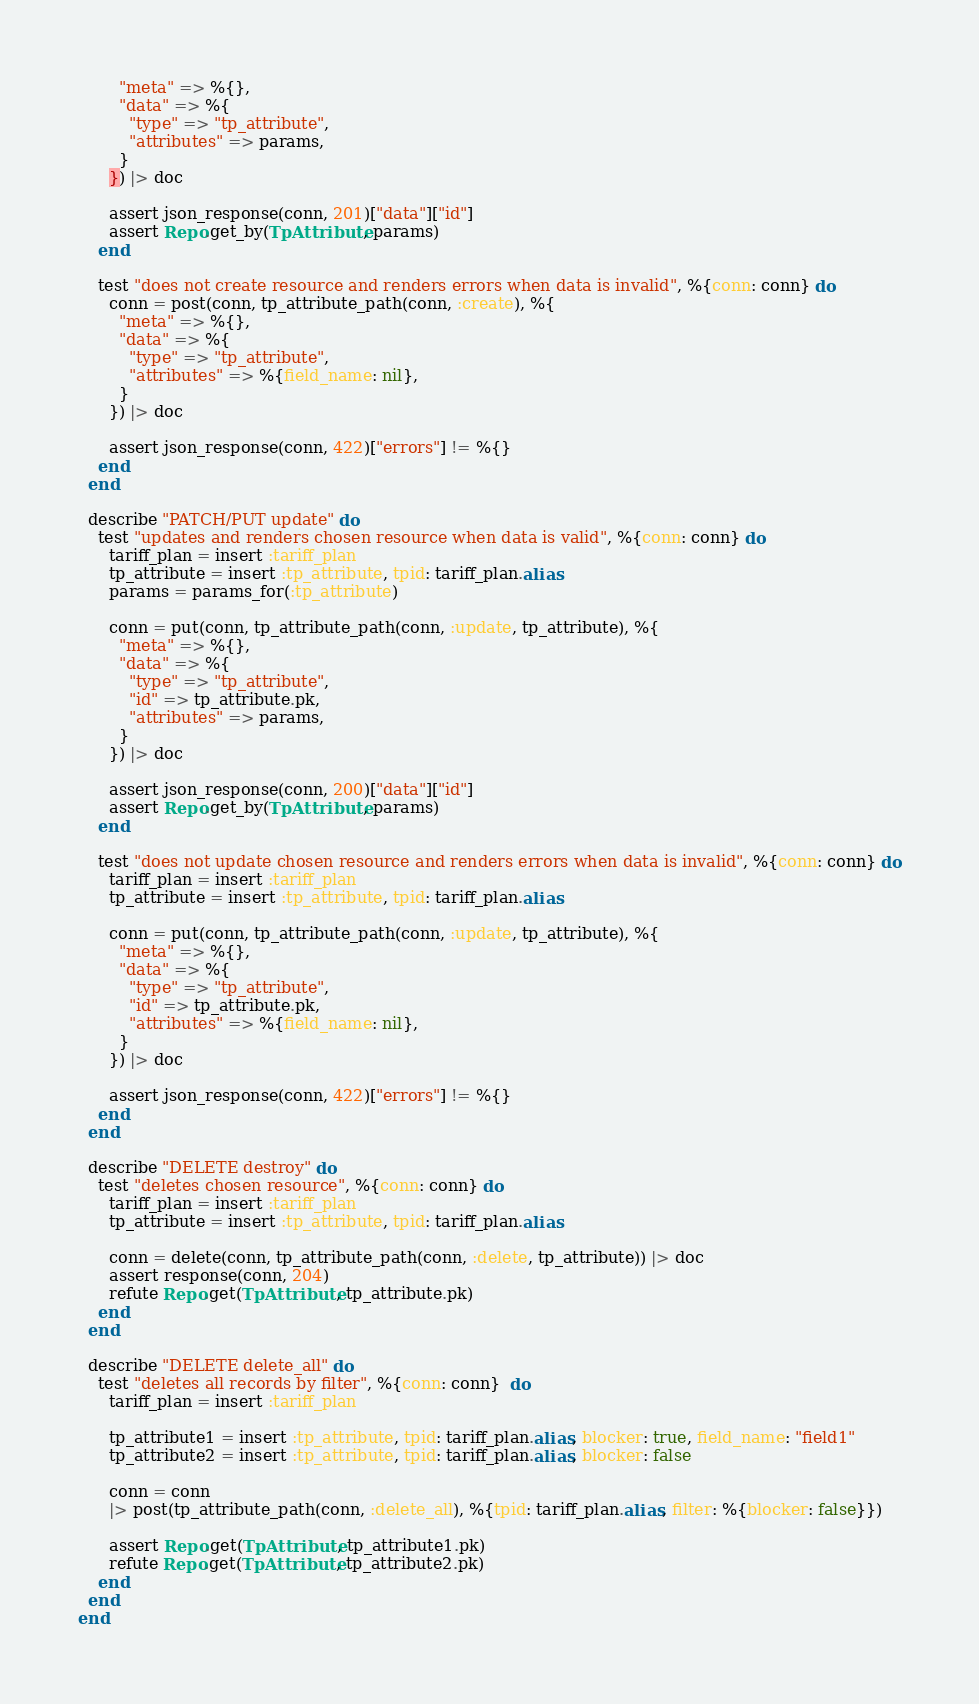<code> <loc_0><loc_0><loc_500><loc_500><_Elixir_>        "meta" => %{},
        "data" => %{
          "type" => "tp_attribute",
          "attributes" => params,
        }
      }) |> doc

      assert json_response(conn, 201)["data"]["id"]
      assert Repo.get_by(TpAttribute, params)
    end

    test "does not create resource and renders errors when data is invalid", %{conn: conn} do
      conn = post(conn, tp_attribute_path(conn, :create), %{
        "meta" => %{},
        "data" => %{
          "type" => "tp_attribute",
          "attributes" => %{field_name: nil},
        }
      }) |> doc

      assert json_response(conn, 422)["errors"] != %{}
    end
  end

  describe "PATCH/PUT update" do
    test "updates and renders chosen resource when data is valid", %{conn: conn} do
      tariff_plan = insert :tariff_plan
      tp_attribute = insert :tp_attribute, tpid: tariff_plan.alias
      params = params_for(:tp_attribute)

      conn = put(conn, tp_attribute_path(conn, :update, tp_attribute), %{
        "meta" => %{},
        "data" => %{
          "type" => "tp_attribute",
          "id" => tp_attribute.pk,
          "attributes" => params,
        }
      }) |> doc

      assert json_response(conn, 200)["data"]["id"]
      assert Repo.get_by(TpAttribute, params)
    end

    test "does not update chosen resource and renders errors when data is invalid", %{conn: conn} do
      tariff_plan = insert :tariff_plan
      tp_attribute = insert :tp_attribute, tpid: tariff_plan.alias

      conn = put(conn, tp_attribute_path(conn, :update, tp_attribute), %{
        "meta" => %{},
        "data" => %{
          "type" => "tp_attribute",
          "id" => tp_attribute.pk,
          "attributes" => %{field_name: nil},
        }
      }) |> doc

      assert json_response(conn, 422)["errors"] != %{}
    end
  end

  describe "DELETE destroy" do
    test "deletes chosen resource", %{conn: conn} do
      tariff_plan = insert :tariff_plan
      tp_attribute = insert :tp_attribute, tpid: tariff_plan.alias

      conn = delete(conn, tp_attribute_path(conn, :delete, tp_attribute)) |> doc
      assert response(conn, 204)
      refute Repo.get(TpAttribute, tp_attribute.pk)
    end
  end

  describe "DELETE delete_all" do
    test "deletes all records by filter", %{conn: conn}  do
      tariff_plan = insert :tariff_plan

      tp_attribute1 = insert :tp_attribute, tpid: tariff_plan.alias, blocker: true, field_name: "field1"
      tp_attribute2 = insert :tp_attribute, tpid: tariff_plan.alias, blocker: false

      conn = conn
      |> post(tp_attribute_path(conn, :delete_all), %{tpid: tariff_plan.alias, filter: %{blocker: false}})

      assert Repo.get(TpAttribute, tp_attribute1.pk)
      refute Repo.get(TpAttribute, tp_attribute2.pk)
    end
  end
end
</code> 